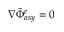Convert formula to latex. <formula><loc_0><loc_0><loc_500><loc_500>\nabla \tilde { \Phi } _ { a s y } ^ { e } = 0</formula> 